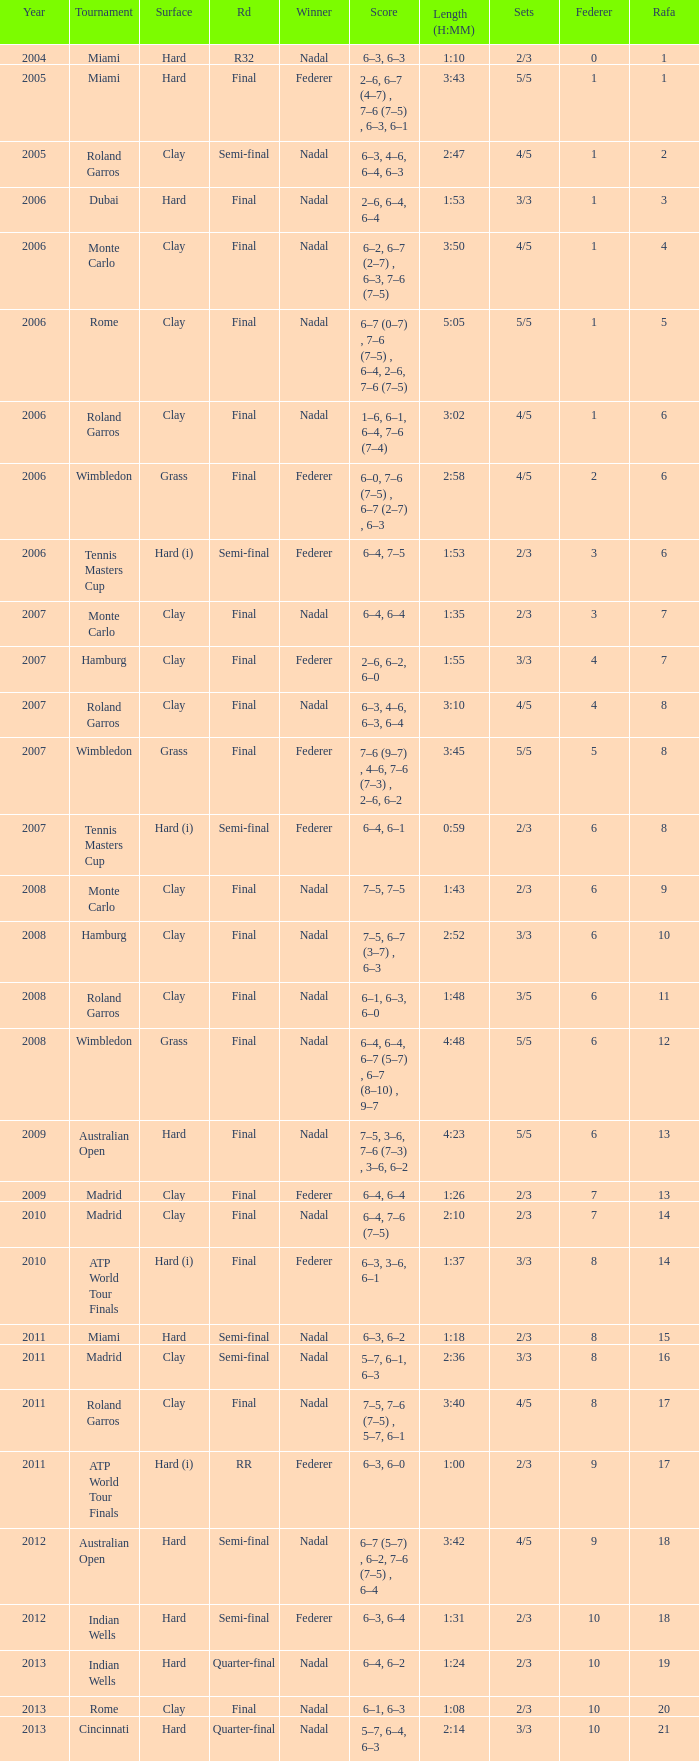What was the nadal in Miami in the final round? 1.0. 